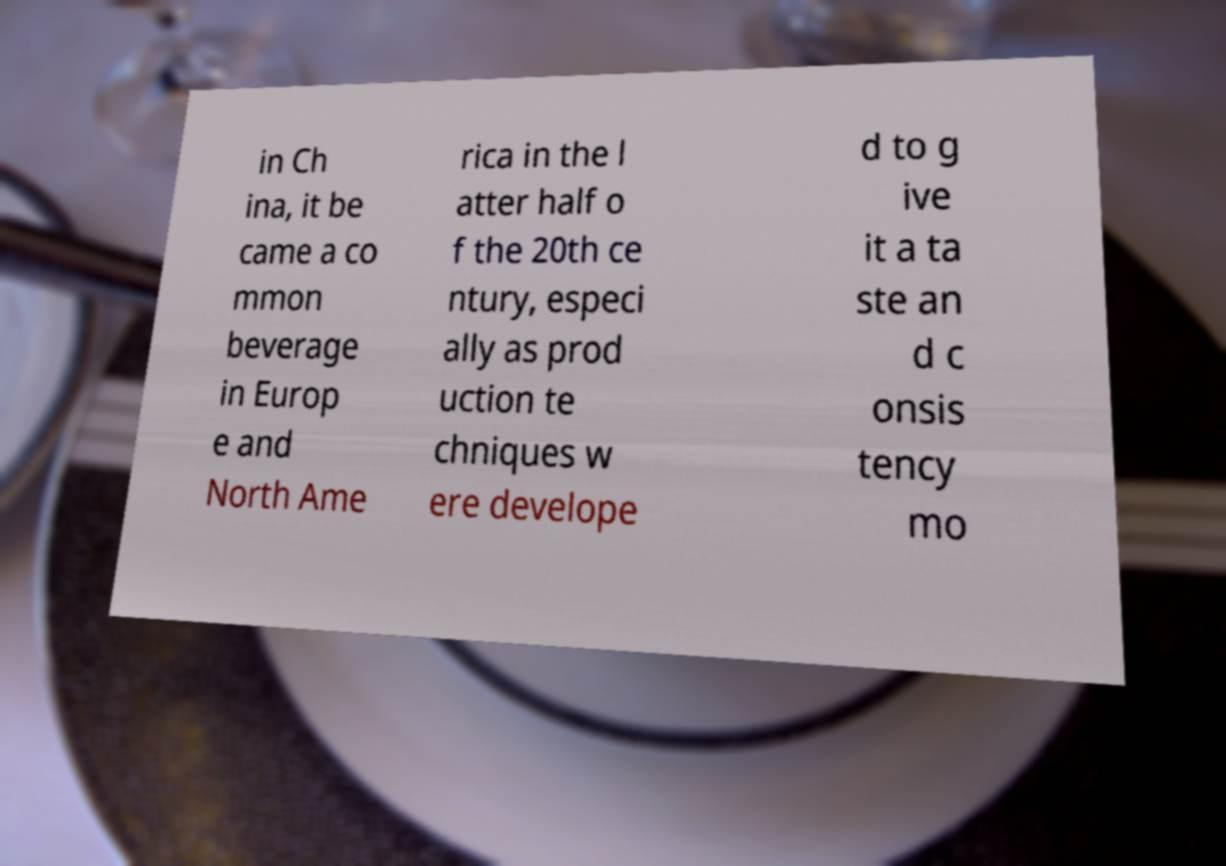Could you assist in decoding the text presented in this image and type it out clearly? in Ch ina, it be came a co mmon beverage in Europ e and North Ame rica in the l atter half o f the 20th ce ntury, especi ally as prod uction te chniques w ere develope d to g ive it a ta ste an d c onsis tency mo 